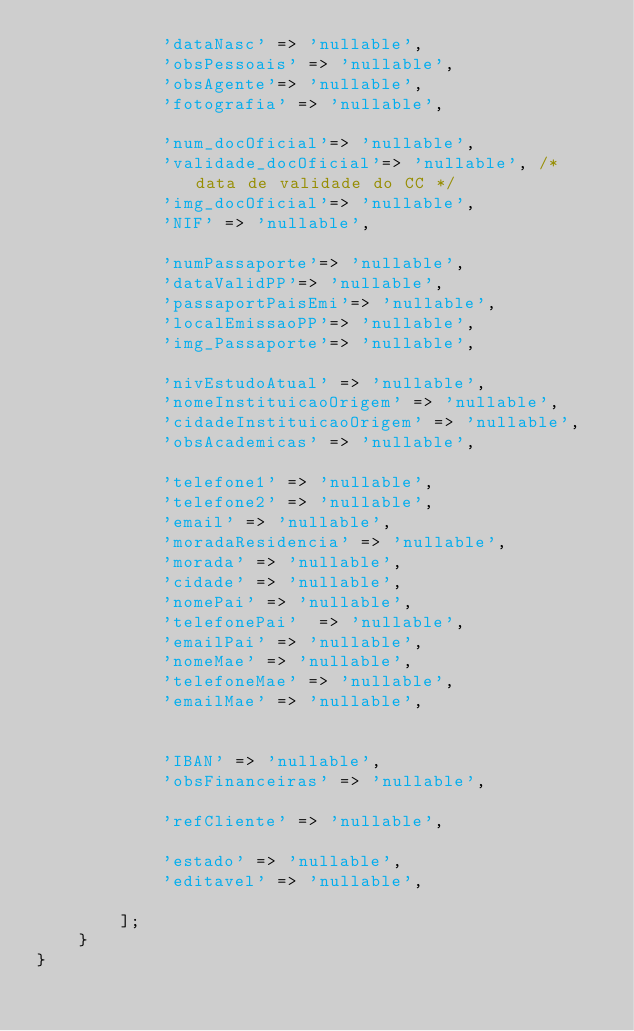<code> <loc_0><loc_0><loc_500><loc_500><_PHP_>            'dataNasc' => 'nullable',
            'obsPessoais' => 'nullable',
            'obsAgente'=> 'nullable',
            'fotografia' => 'nullable',

            'num_docOficial'=> 'nullable',
            'validade_docOficial'=> 'nullable', /* data de validade do CC */
            'img_docOficial'=> 'nullable',
            'NIF' => 'nullable',

            'numPassaporte'=> 'nullable',
            'dataValidPP'=> 'nullable',
            'passaportPaisEmi'=> 'nullable',
            'localEmissaoPP'=> 'nullable',
            'img_Passaporte'=> 'nullable',

            'nivEstudoAtual' => 'nullable',
            'nomeInstituicaoOrigem' => 'nullable',
            'cidadeInstituicaoOrigem' => 'nullable',
            'obsAcademicas' => 'nullable',

            'telefone1' => 'nullable',
            'telefone2' => 'nullable',
            'email' => 'nullable',
            'moradaResidencia' => 'nullable',
            'morada' => 'nullable',
            'cidade' => 'nullable',
            'nomePai' => 'nullable',
            'telefonePai'  => 'nullable',
            'emailPai' => 'nullable',
            'nomeMae' => 'nullable',
            'telefoneMae' => 'nullable',
            'emailMae' => 'nullable',


            'IBAN' => 'nullable',
            'obsFinanceiras' => 'nullable',

            'refCliente' => 'nullable',

            'estado' => 'nullable',
            'editavel' => 'nullable',

        ];
    }
}
</code> 